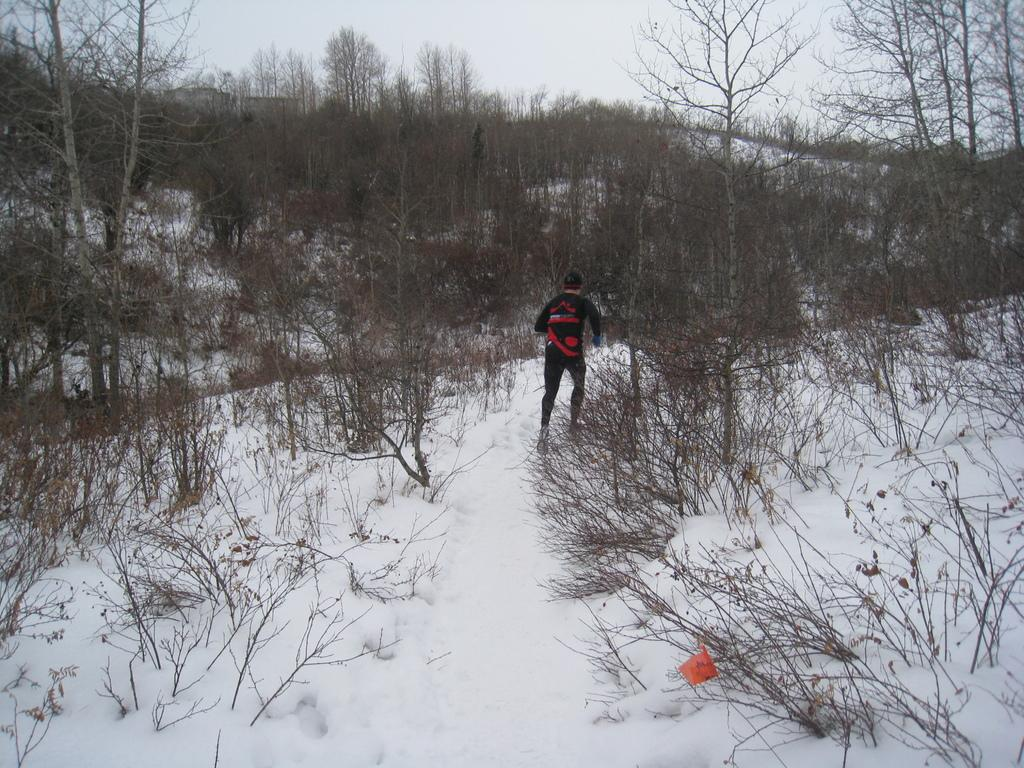Who is the main subject in the image? There is a man in the image. What is the man doing in the image? The man is running on the snow. What type of vegetation can be seen in the image? There are trees in the image. What is visible at the top of the image? The sky is visible at the top of the image. What is the taste of the rabbits in the image? There are no rabbits present in the image, so it is not possible to determine their taste. 